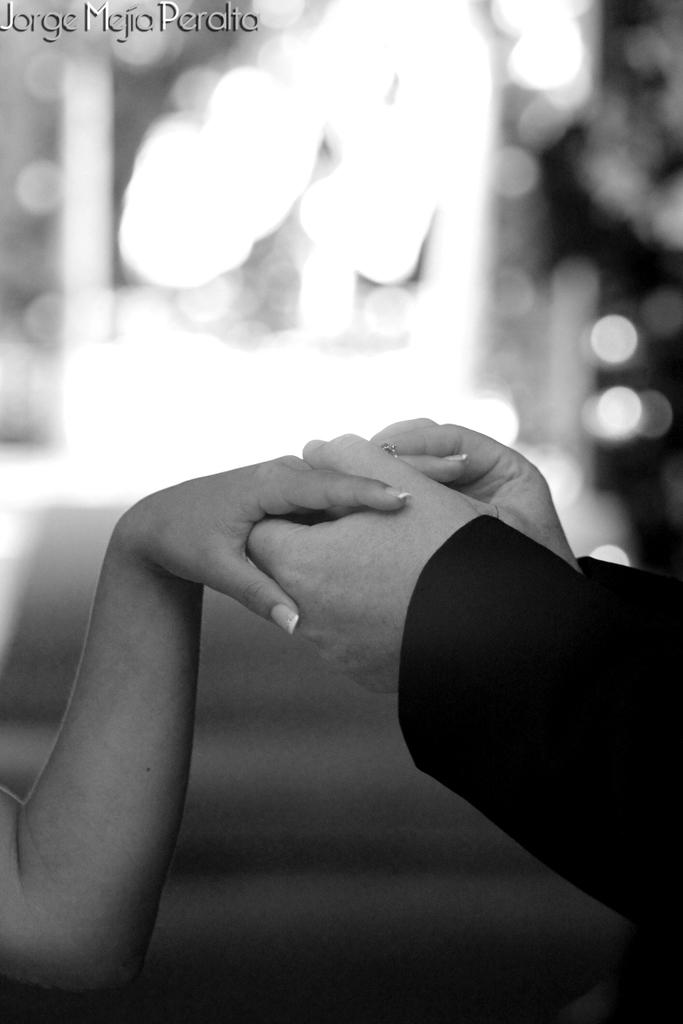What is happening between the two people in the image? There is a person holding another person's hand in the image. What can be observed about the background of the image? The background of the image is blurred. Is there any additional information or marking present in the image? Yes, there is a watermark in the image. What type of orange is being held by the person in the image? There is no orange present in the image; it features two people holding hands. How many thumbs can be seen in the image? It is difficult to determine the exact number of thumbs visible in the image due to the blurred background. What type of shade is covering the person in the image? There is no shade covering the person in the image; the background is blurred, but no shade is mentioned or visible. 